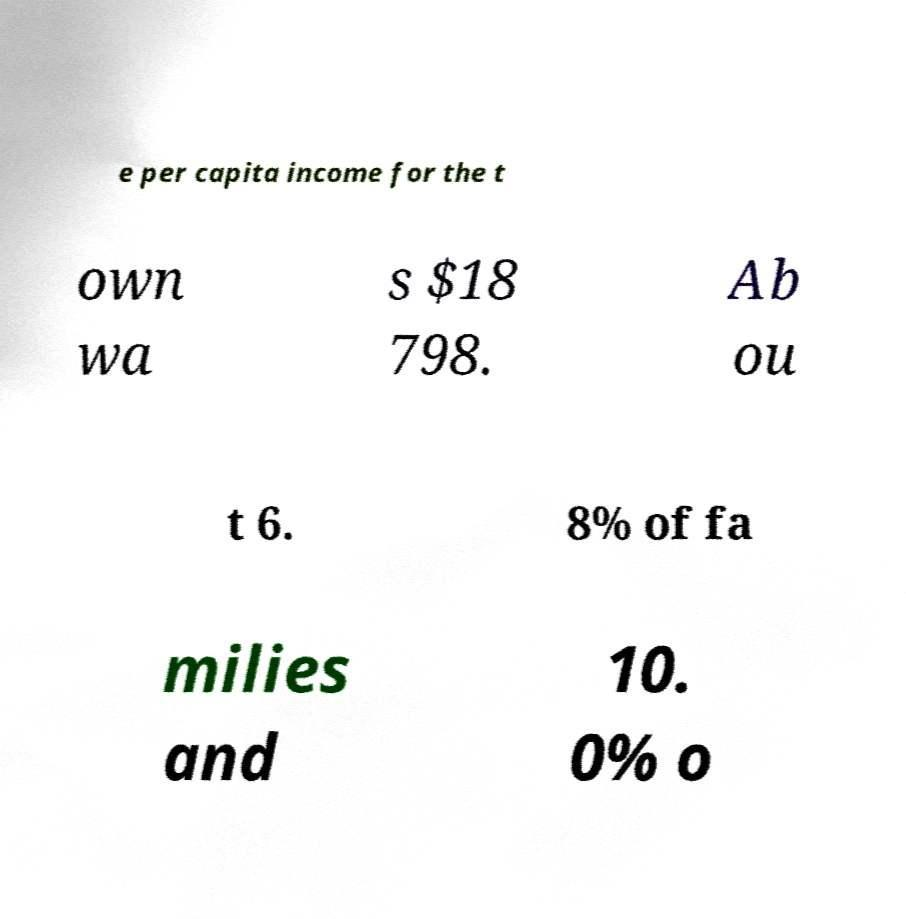Can you read and provide the text displayed in the image?This photo seems to have some interesting text. Can you extract and type it out for me? e per capita income for the t own wa s $18 798. Ab ou t 6. 8% of fa milies and 10. 0% o 